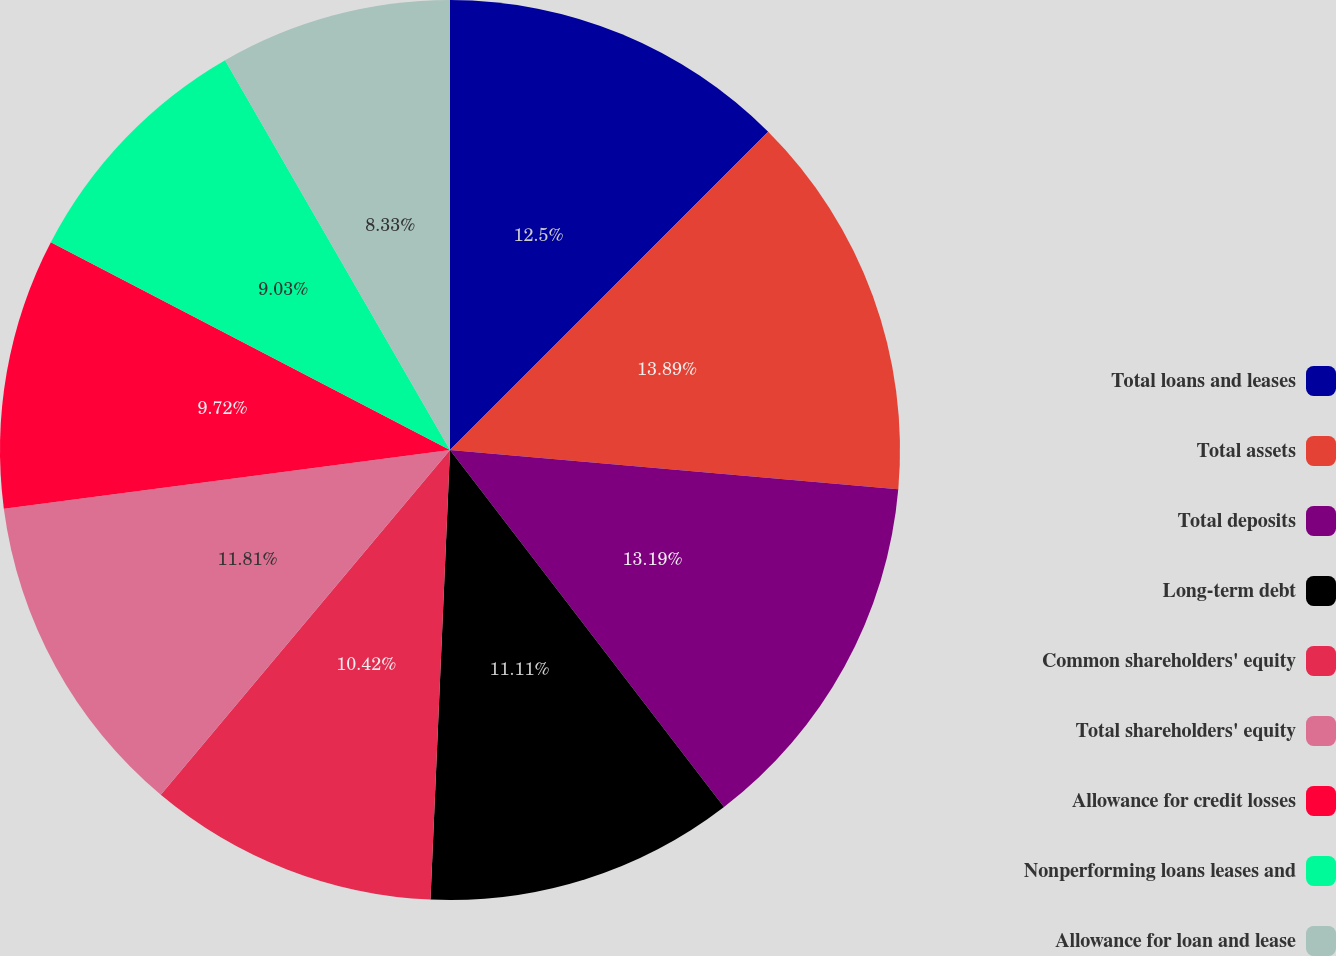Convert chart. <chart><loc_0><loc_0><loc_500><loc_500><pie_chart><fcel>Total loans and leases<fcel>Total assets<fcel>Total deposits<fcel>Long-term debt<fcel>Common shareholders' equity<fcel>Total shareholders' equity<fcel>Allowance for credit losses<fcel>Nonperforming loans leases and<fcel>Allowance for loan and lease<nl><fcel>12.5%<fcel>13.89%<fcel>13.19%<fcel>11.11%<fcel>10.42%<fcel>11.81%<fcel>9.72%<fcel>9.03%<fcel>8.33%<nl></chart> 